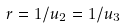Convert formula to latex. <formula><loc_0><loc_0><loc_500><loc_500>r = 1 / u _ { 2 } = 1 / u _ { 3 }</formula> 